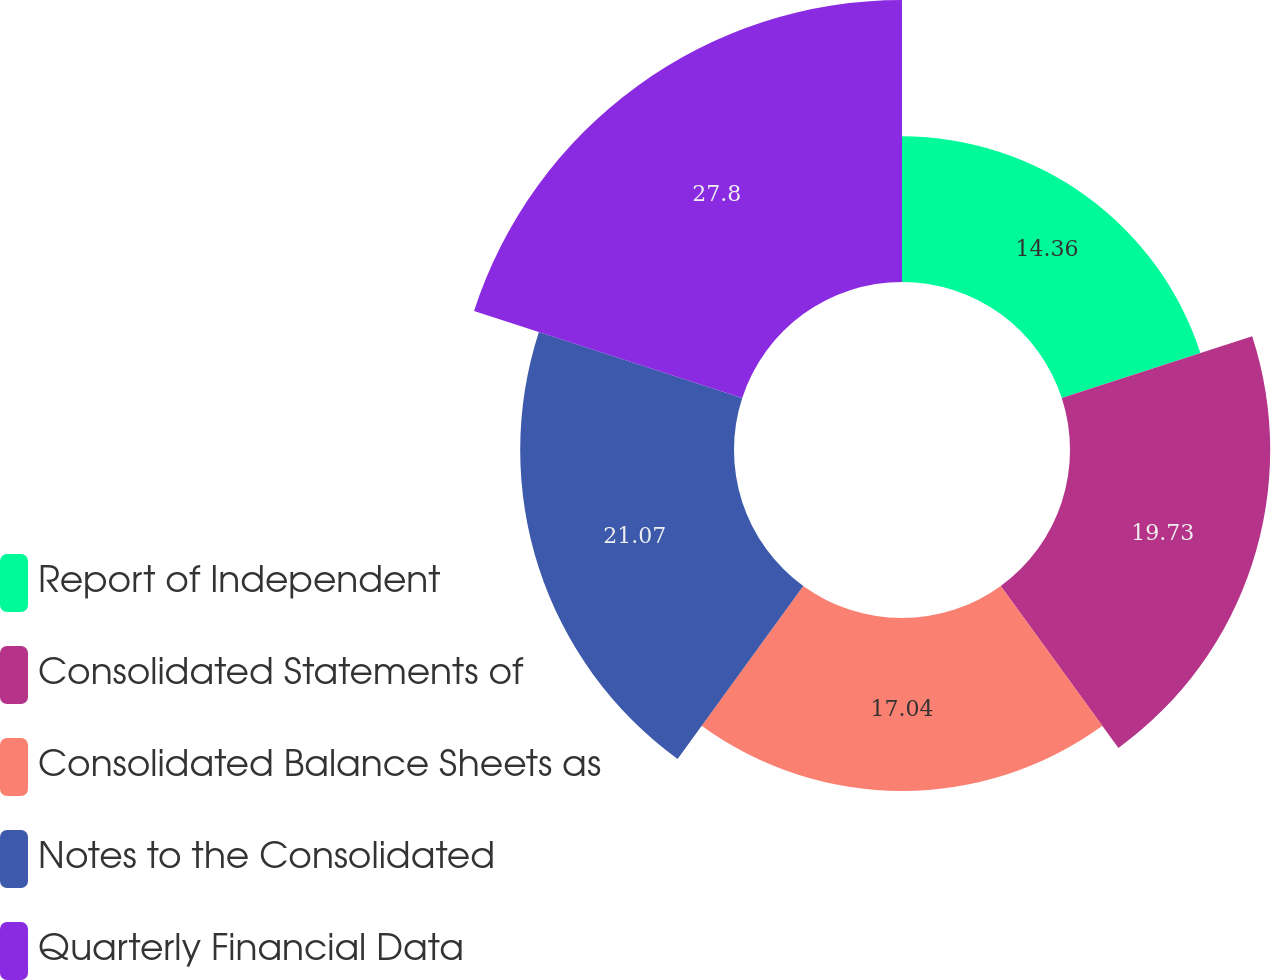Convert chart. <chart><loc_0><loc_0><loc_500><loc_500><pie_chart><fcel>Report of Independent<fcel>Consolidated Statements of<fcel>Consolidated Balance Sheets as<fcel>Notes to the Consolidated<fcel>Quarterly Financial Data<nl><fcel>14.36%<fcel>19.73%<fcel>17.04%<fcel>21.07%<fcel>27.79%<nl></chart> 